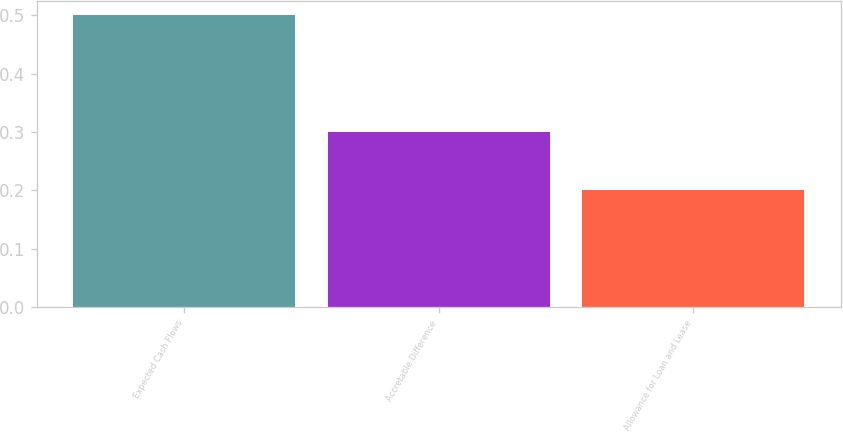Convert chart. <chart><loc_0><loc_0><loc_500><loc_500><bar_chart><fcel>Expected Cash Flows<fcel>Accretable Difference<fcel>Allowance for Loan and Lease<nl><fcel>0.5<fcel>0.3<fcel>0.2<nl></chart> 